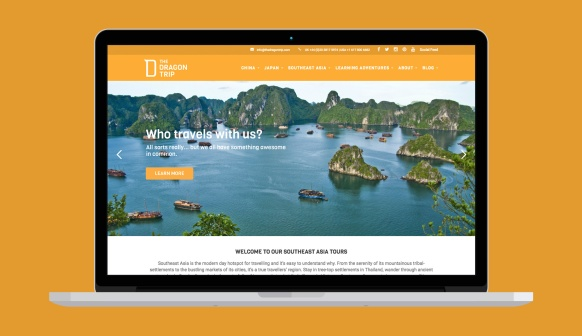Imagine this seascape is actually part of an ancient supercontinent and holds untold secrets of the past. What mysteries might be hidden here? Picture this seascape as remnants of an ancient supercontinent, with each island holding fragments of a long-lost civilization. Beneath the waters, submerged cities with towering statues hint at a society with advanced architectural skills and possibly even wisdom lost to time. As explorers venture into the caves and underwater relics, they uncover ancient artifacts, written scripts in unknown languages, and intricate murals that tell tales of epic battles, celestial events, and diplomacy that shaped the ancient world's fate. Each island could reveal hidden technology, guiding researchers to revolutionize modern science, culture, or even a new understanding of humanity's origins. The mix of natural beauty and historical intrigue would draw adventurers, historians, and scientists to uncover the secrets of this mysterious, ancient supercontinent. 